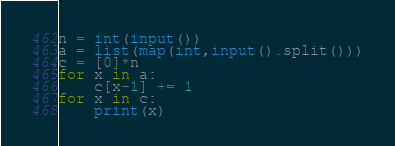Convert code to text. <code><loc_0><loc_0><loc_500><loc_500><_Python_>n = int(input())
a = list(map(int,input().split()))
c = [0]*n
for x in a:
    c[x-1] += 1
for x in c:
    print(x)
</code> 